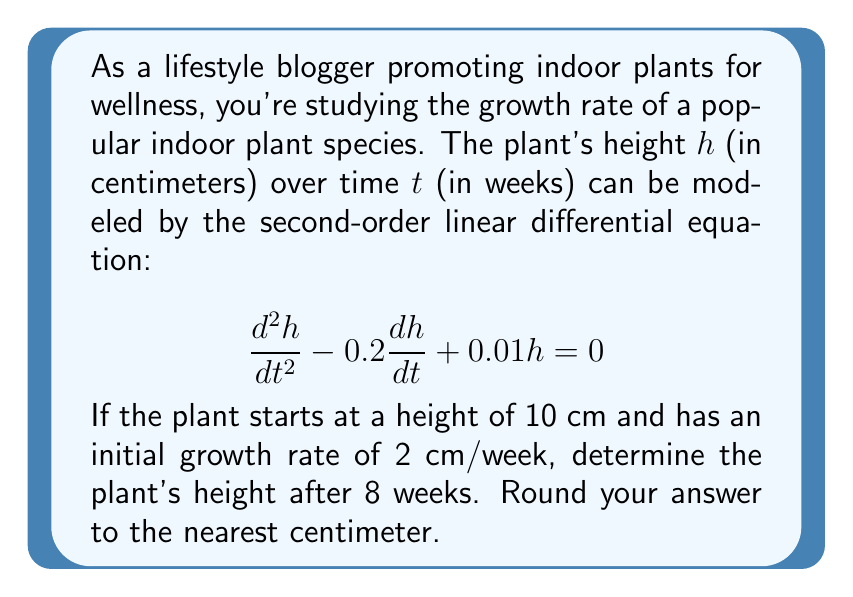Provide a solution to this math problem. To solve this problem, we'll follow these steps:

1) The characteristic equation for this differential equation is:
   $$r^2 - 0.2r + 0.01 = 0$$

2) Solving this quadratic equation:
   $$r = \frac{0.2 \pm \sqrt{0.04 - 0.04}}{2} = 0.1$$

3) Since we have a repeated root, the general solution is:
   $$h(t) = c_1e^{0.1t} + c_2te^{0.1t}$$

4) We need to find $c_1$ and $c_2$ using the initial conditions:
   At $t=0$, $h(0) = 10$ and $h'(0) = 2$

5) From $h(0) = 10$:
   $$10 = c_1$$

6) From $h'(t) = 0.1c_1e^{0.1t} + c_2e^{0.1t} + 0.1c_2te^{0.1t}$, we get:
   $$2 = 0.1c_1 + c_2$$

7) Substituting $c_1 = 10$:
   $$2 = 1 + c_2$$
   $$c_2 = 1$$

8) Therefore, our particular solution is:
   $$h(t) = 10e^{0.1t} + te^{0.1t}$$

9) To find the height at 8 weeks:
   $$h(8) = 10e^{0.8} + 8e^{0.8}$$
   $$= 10(2.2255) + 8(2.2255)$$
   $$= 22.255 + 17.804$$
   $$= 40.059$$

10) Rounding to the nearest centimeter:
    $$h(8) \approx 40 \text{ cm}$$
Answer: 40 cm 